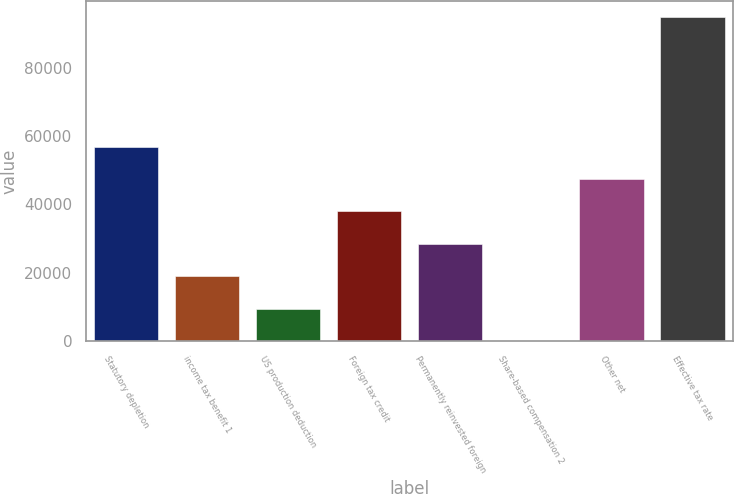Convert chart. <chart><loc_0><loc_0><loc_500><loc_500><bar_chart><fcel>Statutory depletion<fcel>income tax benefit 1<fcel>US production deduction<fcel>Foreign tax credit<fcel>Permanently reinvested foreign<fcel>Share-based compensation 2<fcel>Other net<fcel>Effective tax rate<nl><fcel>56966.9<fcel>18990.9<fcel>9496.86<fcel>37978.9<fcel>28484.9<fcel>2.85<fcel>47472.9<fcel>94943<nl></chart> 